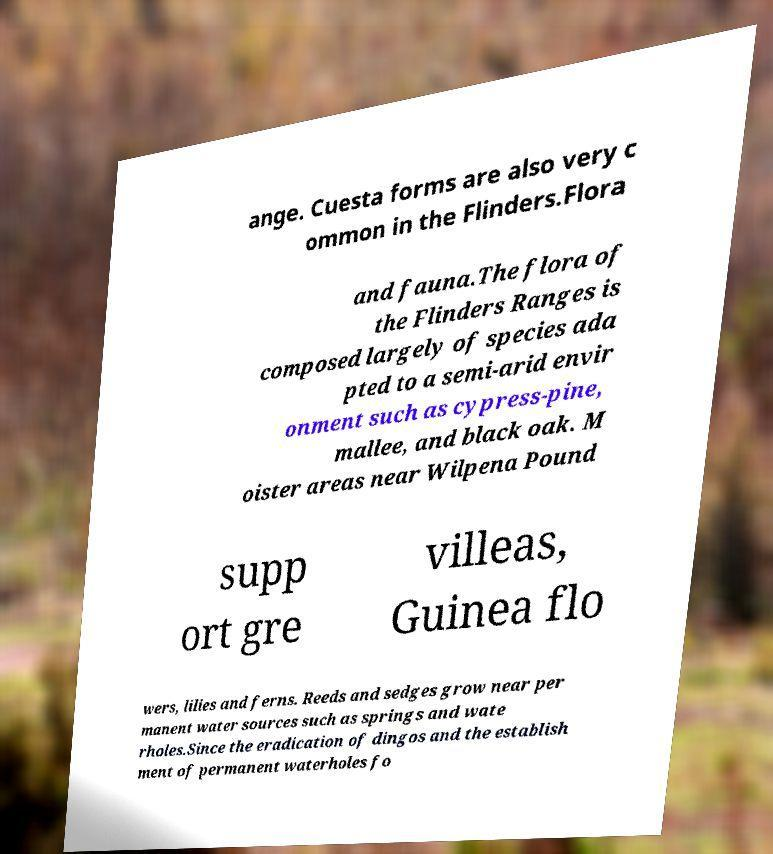What messages or text are displayed in this image? I need them in a readable, typed format. ange. Cuesta forms are also very c ommon in the Flinders.Flora and fauna.The flora of the Flinders Ranges is composed largely of species ada pted to a semi-arid envir onment such as cypress-pine, mallee, and black oak. M oister areas near Wilpena Pound supp ort gre villeas, Guinea flo wers, lilies and ferns. Reeds and sedges grow near per manent water sources such as springs and wate rholes.Since the eradication of dingos and the establish ment of permanent waterholes fo 